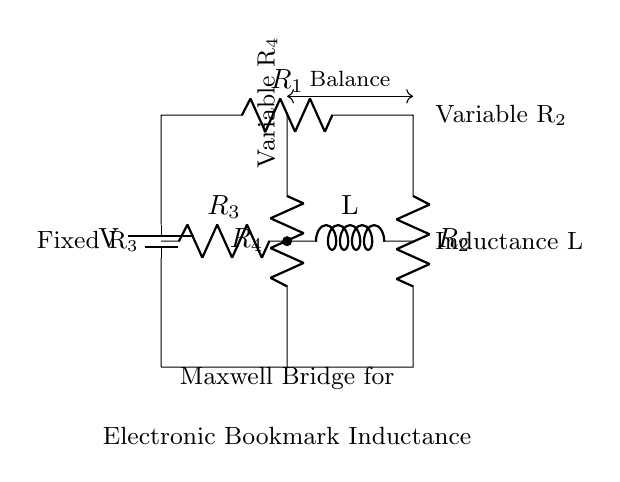What type of circuit is represented? The circuit is a Maxwell Bridge, which is specifically designed for measuring inductance. It is characterized by its arrangement of resistors and an inductor to achieve a balance.
Answer: Maxwell Bridge What does L represent in this circuit? L denotes the inductance value of the inductor component within the circuit. This is the primary quantity the bridge aims to measure accurately.
Answer: Inductance Which component is adjustable in this circuit? The circuit includes two adjustable components, which are R2 and R4, that allow for fine-tuning to achieve a balanced condition.
Answer: R2 and R4 What does the balance condition indicate? The balance condition signifies that the bridge is correctly calibrated, often achieved when the ratio of the resistors is equal, indicating a measurement point for the inductance.
Answer: Calibration How many resistors are present in the circuit? The circuit features four resistors, labeled R1, R2, R3, and R4, each serving a specific role in achieving the balance necessary for measuring the inductance of L.
Answer: Four What is the primary function of this Maxwell Bridge? The main function of the Maxwell Bridge is to measure the inductance of an unknown inductor by balancing the circuit and observing the necessary adjustments to the variable resistors.
Answer: Measure inductance 